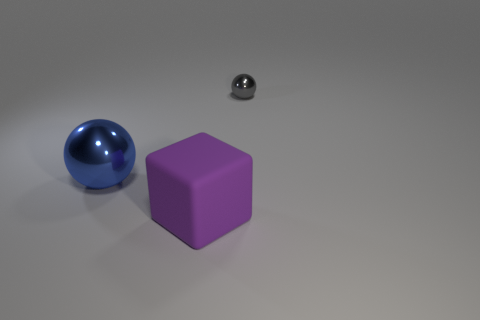Add 1 big blue spheres. How many objects exist? 4 Subtract all cubes. How many objects are left? 2 Add 3 shiny things. How many shiny things are left? 5 Add 3 tiny gray metallic objects. How many tiny gray metallic objects exist? 4 Subtract 0 blue cylinders. How many objects are left? 3 Subtract all cyan metal objects. Subtract all purple blocks. How many objects are left? 2 